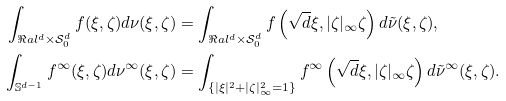Convert formula to latex. <formula><loc_0><loc_0><loc_500><loc_500>\int _ { \Re a l ^ { d } \times \mathcal { S } _ { 0 } ^ { d } } f ( \xi , \zeta ) d \nu ( \xi , \zeta ) & = \int _ { \Re a l ^ { d } \times \mathcal { S } _ { 0 } ^ { d } } f \left ( \sqrt { d } \xi , | \zeta | _ { \infty } \zeta \right ) d \tilde { \nu } ( \xi , \zeta ) , \\ \int _ { \mathbb { S } ^ { d - 1 } } f ^ { \infty } ( \xi , \zeta ) d \nu ^ { \infty } ( \xi , \zeta ) & = \int _ { \{ | \xi | ^ { 2 } + | \zeta | _ { \infty } ^ { 2 } = 1 \} } f ^ { \infty } \left ( \sqrt { d } \xi , | \zeta | _ { \infty } \zeta \right ) d \tilde { \nu } ^ { \infty } ( \xi , \zeta ) .</formula> 